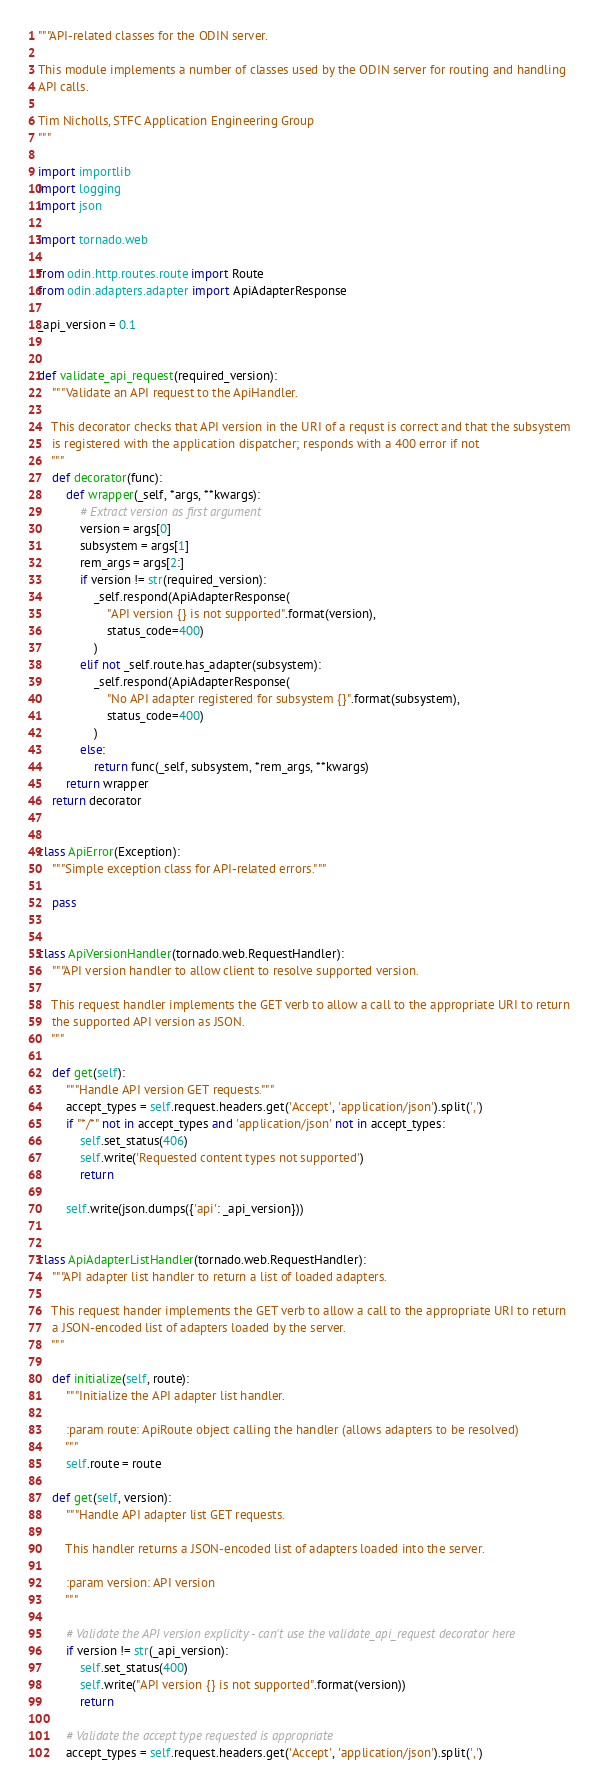<code> <loc_0><loc_0><loc_500><loc_500><_Python_>"""API-related classes for the ODIN server.

This module implements a number of classes used by the ODIN server for routing and handling
API calls.

Tim Nicholls, STFC Application Engineering Group
"""

import importlib
import logging
import json

import tornado.web

from odin.http.routes.route import Route
from odin.adapters.adapter import ApiAdapterResponse

_api_version = 0.1


def validate_api_request(required_version):
    """Validate an API request to the ApiHandler.

    This decorator checks that API version in the URI of a requst is correct and that the subsystem
    is registered with the application dispatcher; responds with a 400 error if not
    """
    def decorator(func):
        def wrapper(_self, *args, **kwargs):
            # Extract version as first argument
            version = args[0]
            subsystem = args[1]
            rem_args = args[2:]
            if version != str(required_version):
                _self.respond(ApiAdapterResponse(
                    "API version {} is not supported".format(version),
                    status_code=400)
                )
            elif not _self.route.has_adapter(subsystem):
                _self.respond(ApiAdapterResponse(
                    "No API adapter registered for subsystem {}".format(subsystem),
                    status_code=400)
                )
            else:
                return func(_self, subsystem, *rem_args, **kwargs)
        return wrapper
    return decorator


class ApiError(Exception):
    """Simple exception class for API-related errors."""

    pass


class ApiVersionHandler(tornado.web.RequestHandler):
    """API version handler to allow client to resolve supported version.

    This request handler implements the GET verb to allow a call to the appropriate URI to return
    the supported API version as JSON.
    """

    def get(self):
        """Handle API version GET requests."""
        accept_types = self.request.headers.get('Accept', 'application/json').split(',')
        if "*/*" not in accept_types and 'application/json' not in accept_types:
            self.set_status(406)
            self.write('Requested content types not supported')
            return

        self.write(json.dumps({'api': _api_version}))


class ApiAdapterListHandler(tornado.web.RequestHandler):
    """API adapter list handler to return a list of loaded adapters.

    This request hander implements the GET verb to allow a call to the appropriate URI to return
    a JSON-encoded list of adapters loaded by the server.
    """

    def initialize(self, route):
        """Initialize the API adapter list handler.

        :param route: ApiRoute object calling the handler (allows adapters to be resolved)
        """
        self.route = route

    def get(self, version):
        """Handle API adapter list GET requests.

        This handler returns a JSON-encoded list of adapters loaded into the server.

        :param version: API version
        """

        # Validate the API version explicity - can't use the validate_api_request decorator here
        if version != str(_api_version):
            self.set_status(400)
            self.write("API version {} is not supported".format(version))
            return

        # Validate the accept type requested is appropriate
        accept_types = self.request.headers.get('Accept', 'application/json').split(',')</code> 